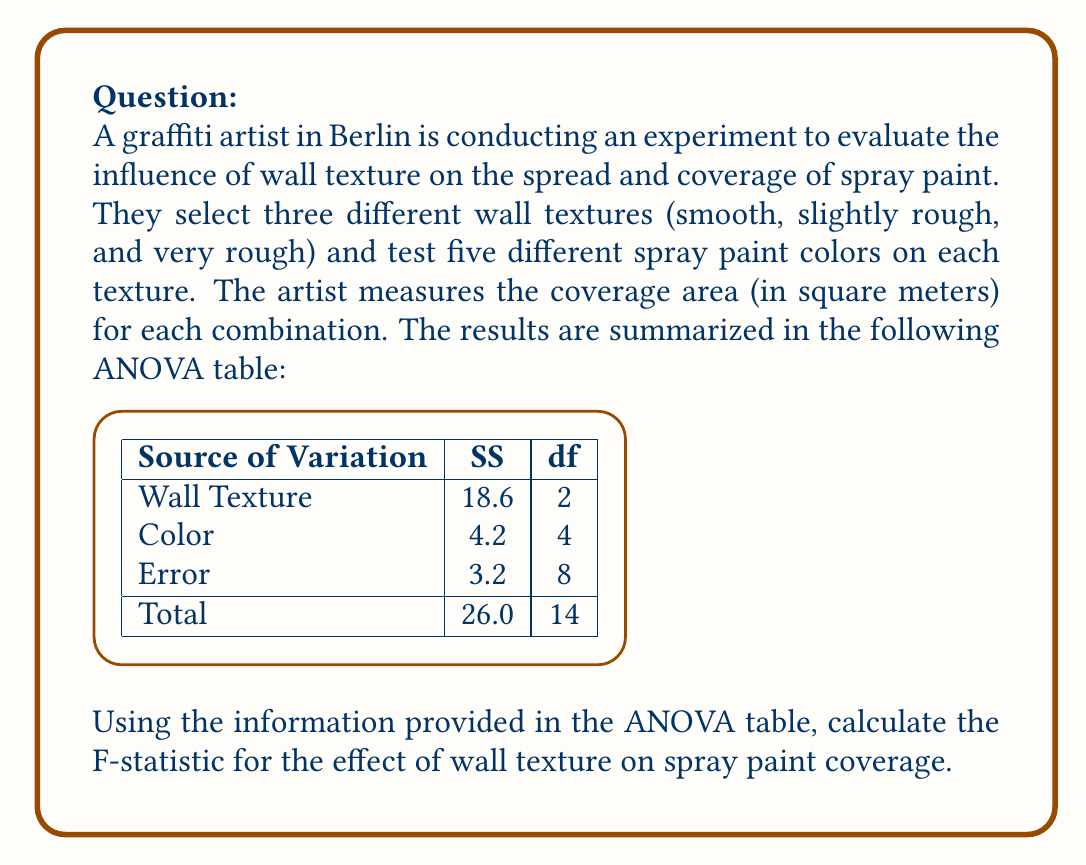Can you answer this question? To calculate the F-statistic for the effect of wall texture, we need to follow these steps:

1. Calculate the Mean Square (MS) for Wall Texture:
   $$ MS_{WallTexture} = \frac{SS_{WallTexture}}{df_{WallTexture}} = \frac{18.6}{2} = 9.3 $$

2. Calculate the Mean Square Error (MSE):
   $$ MSE = \frac{SS_{Error}}{df_{Error}} = \frac{3.2}{8} = 0.4 $$

3. Calculate the F-statistic:
   $$ F = \frac{MS_{WallTexture}}{MSE} = \frac{9.3}{0.4} = 23.25 $$

The F-statistic is the ratio of the Mean Square for the factor (Wall Texture) to the Mean Square Error. This value represents the ratio of the variance explained by the wall texture to the unexplained variance.

A larger F-statistic indicates a stronger effect of the wall texture on spray paint coverage. To determine if this effect is statistically significant, we would compare this F-value to the critical F-value from an F-distribution table, using the degrees of freedom for Wall Texture (2) and Error (8).
Answer: $F = 23.25$ 